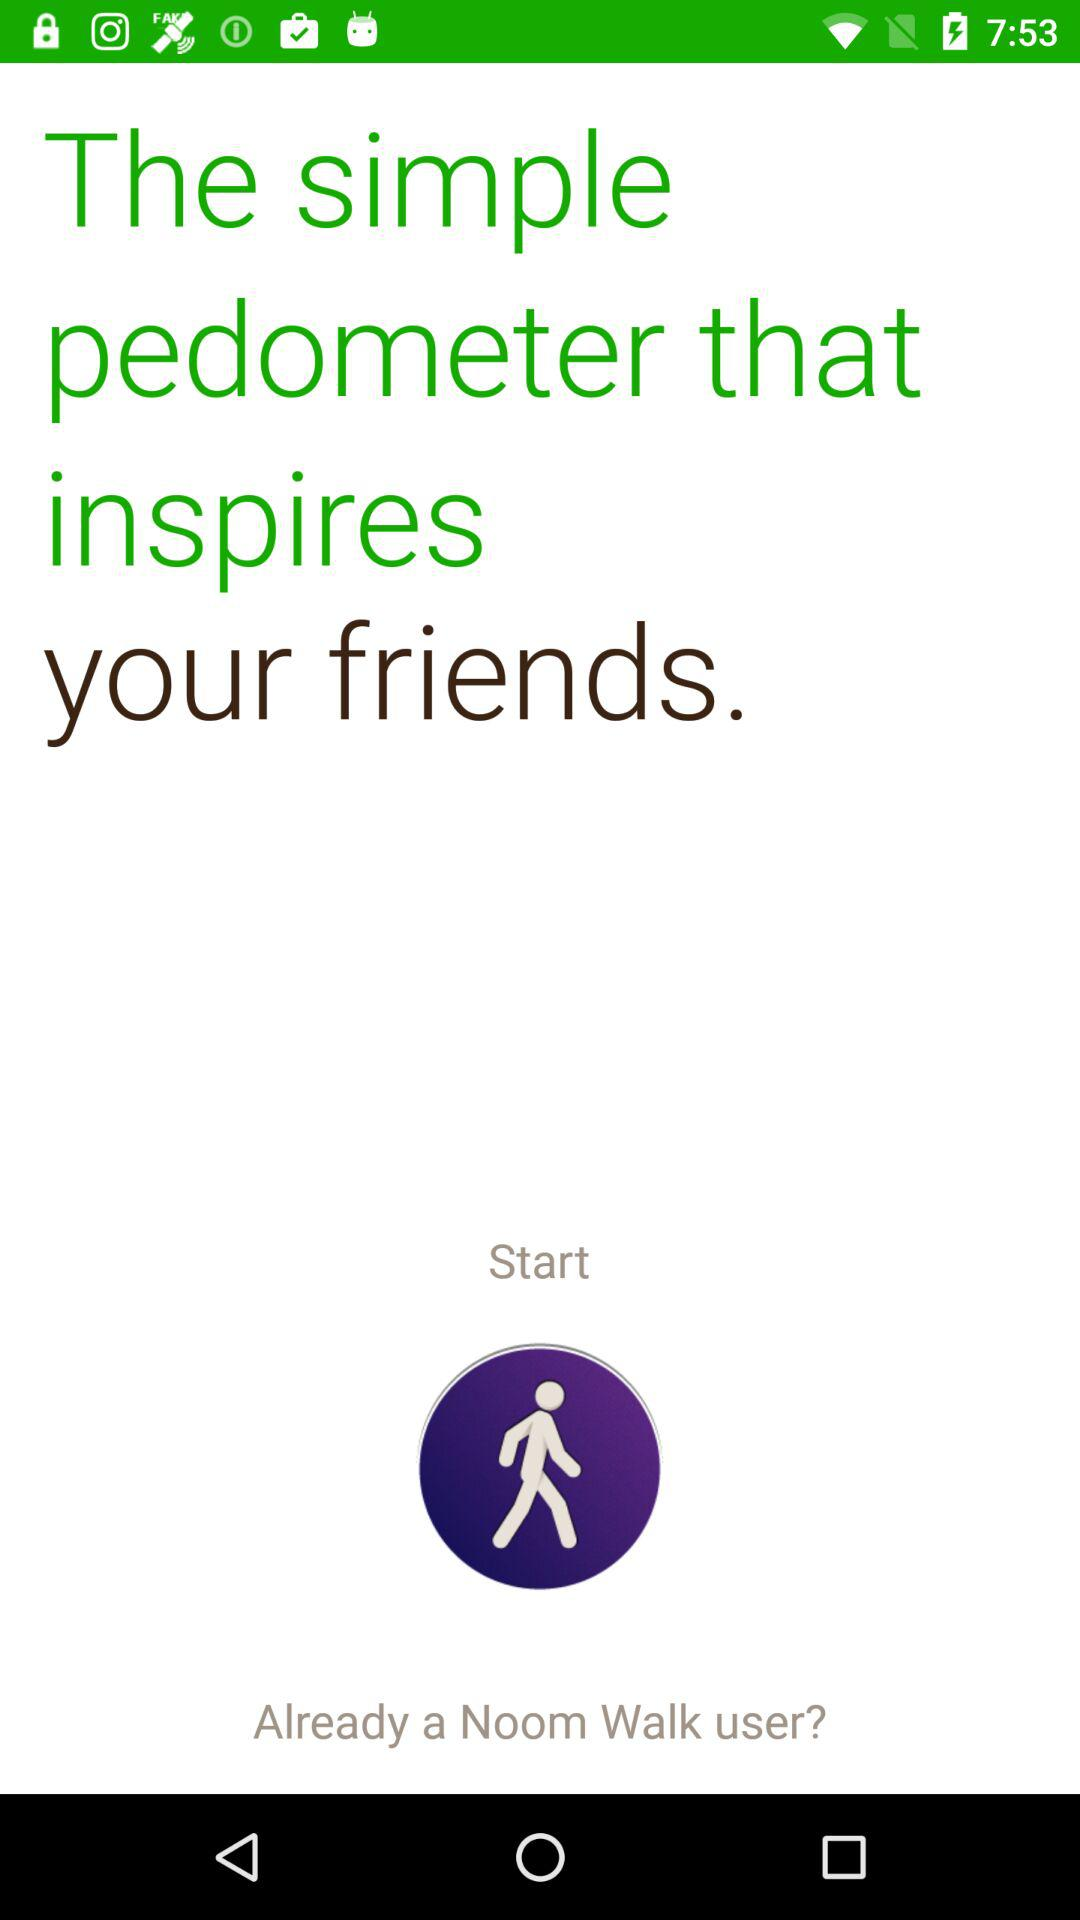What inspires my friends? The one that inspires your friends is the application "simple pedometer". 